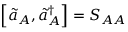Convert formula to latex. <formula><loc_0><loc_0><loc_500><loc_500>\left [ \tilde { a } _ { A } , \tilde { a } _ { A } ^ { \dagger } \right ] = S _ { A A }</formula> 